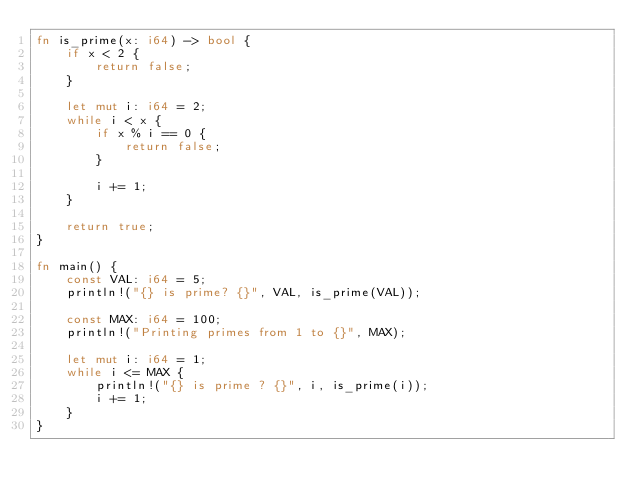Convert code to text. <code><loc_0><loc_0><loc_500><loc_500><_Rust_>fn is_prime(x: i64) -> bool {
    if x < 2 {
        return false;
    }
    
    let mut i: i64 = 2;
    while i < x {
        if x % i == 0 {
            return false;
        }
        
        i += 1;
    }
    
    return true;
}

fn main() {
    const VAL: i64 = 5;
    println!("{} is prime? {}", VAL, is_prime(VAL));

    const MAX: i64 = 100;
    println!("Printing primes from 1 to {}", MAX);

    let mut i: i64 = 1;
    while i <= MAX {
        println!("{} is prime ? {}", i, is_prime(i));
        i += 1;
    }
}
</code> 